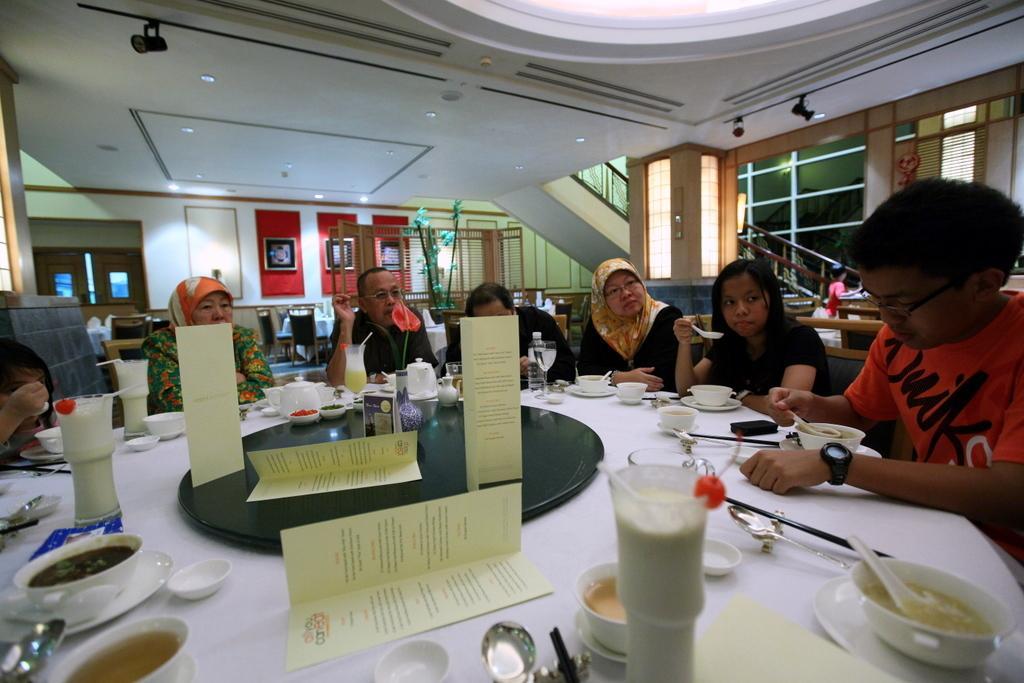Could you give a brief overview of what you see in this image? In this image I can see a group of people are sitting around the dining table and having the food and there are glasses and food bowls with spoons and forks on the dining table. At the back side there is the staircase, at the top there are ceiling lights. 